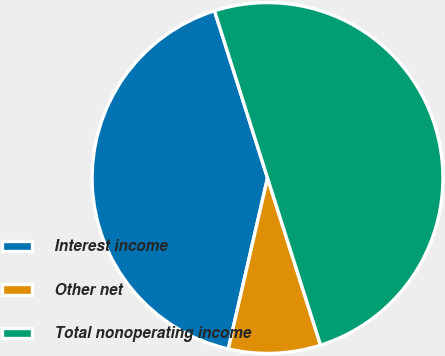Convert chart to OTSL. <chart><loc_0><loc_0><loc_500><loc_500><pie_chart><fcel>Interest income<fcel>Other net<fcel>Total nonoperating income<nl><fcel>41.52%<fcel>8.48%<fcel>50.0%<nl></chart> 